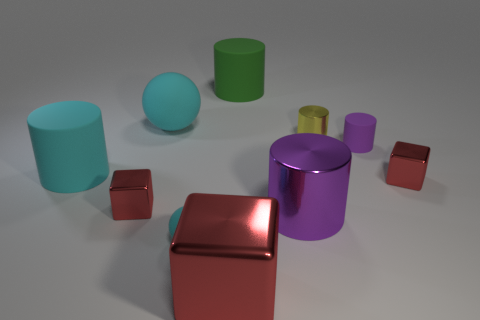How many rubber objects are big purple cylinders or cyan spheres?
Ensure brevity in your answer.  2. What number of small cyan matte things are left of the tiny red shiny block that is to the left of the small metallic cylinder?
Offer a very short reply. 0. How many large red things have the same material as the large red cube?
Ensure brevity in your answer.  0. What number of big things are cyan rubber cylinders or green cylinders?
Make the answer very short. 2. There is a cyan object that is both in front of the tiny yellow cylinder and behind the large purple shiny object; what is its shape?
Your answer should be very brief. Cylinder. Is the large cyan sphere made of the same material as the green object?
Provide a succinct answer. Yes. There is a matte sphere that is the same size as the cyan cylinder; what is its color?
Provide a short and direct response. Cyan. What color is the cube that is both to the left of the yellow metal cylinder and behind the large purple shiny object?
Offer a very short reply. Red. What is the size of the rubber thing that is the same color as the large metallic cylinder?
Give a very brief answer. Small. What shape is the large matte thing that is the same color as the big sphere?
Your answer should be very brief. Cylinder. 